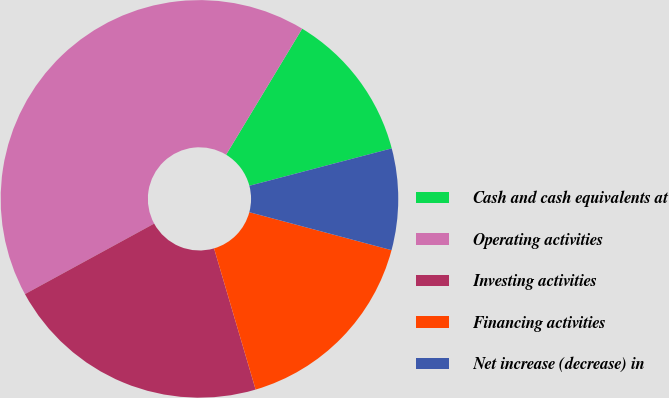Convert chart. <chart><loc_0><loc_0><loc_500><loc_500><pie_chart><fcel>Cash and cash equivalents at<fcel>Operating activities<fcel>Investing activities<fcel>Financing activities<fcel>Net increase (decrease) in<nl><fcel>12.27%<fcel>41.59%<fcel>21.61%<fcel>16.29%<fcel>8.24%<nl></chart> 